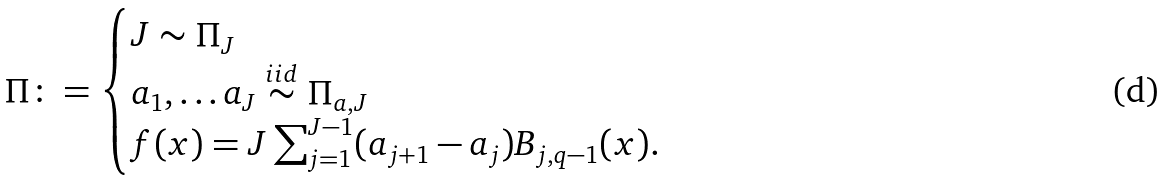Convert formula to latex. <formula><loc_0><loc_0><loc_500><loc_500>\Pi \colon = \begin{cases} J \sim \Pi _ { J } \\ a _ { 1 } , \dots a _ { J } \overset { i i d } { \sim } \Pi _ { a , J } \\ f ( x ) = { J } \sum _ { j = 1 } ^ { J - 1 } ( a _ { j + 1 } - a _ { j } ) B _ { j , q - 1 } ( x ) . \end{cases}</formula> 